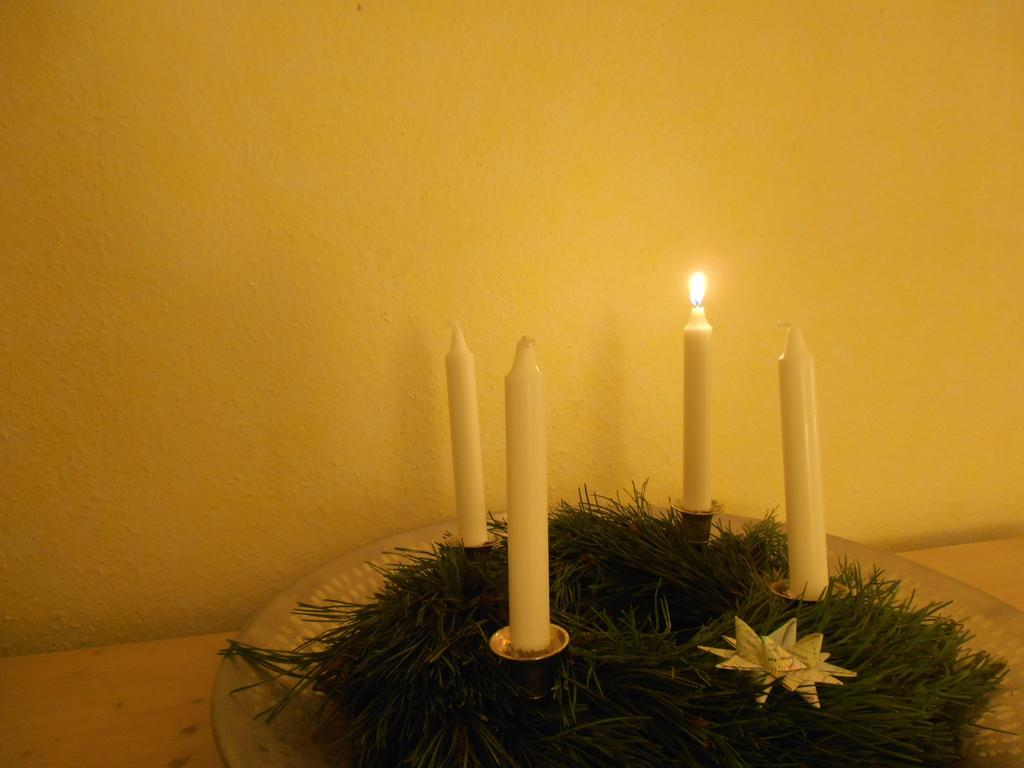What type of candles are present in the image? There are white color candles in the image. What color is the wall in the image? The wall in the image is yellow in color. What type of polish is being applied to the candles in the image? There is no indication in the image that any polish is being applied to the candles. 